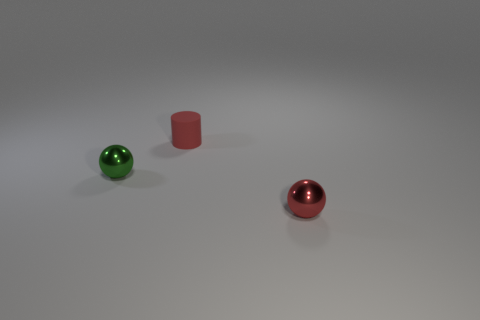Does the small red metallic thing have the same shape as the tiny green metal object?
Keep it short and to the point. Yes. Are there any other things that are the same material as the red cylinder?
Your response must be concise. No. Is there another sphere that has the same size as the green sphere?
Offer a very short reply. Yes. What material is the green object that is the same size as the red matte cylinder?
Your answer should be compact. Metal. Is there a green thing that has the same shape as the tiny red metal object?
Offer a very short reply. Yes. What material is the thing that is the same color as the tiny cylinder?
Ensure brevity in your answer.  Metal. What shape is the object that is behind the green thing?
Your answer should be very brief. Cylinder. How many large matte things are there?
Provide a short and direct response. 0. What is the color of the small thing that is made of the same material as the green sphere?
Provide a short and direct response. Red. How many large objects are green spheres or cylinders?
Keep it short and to the point. 0. 